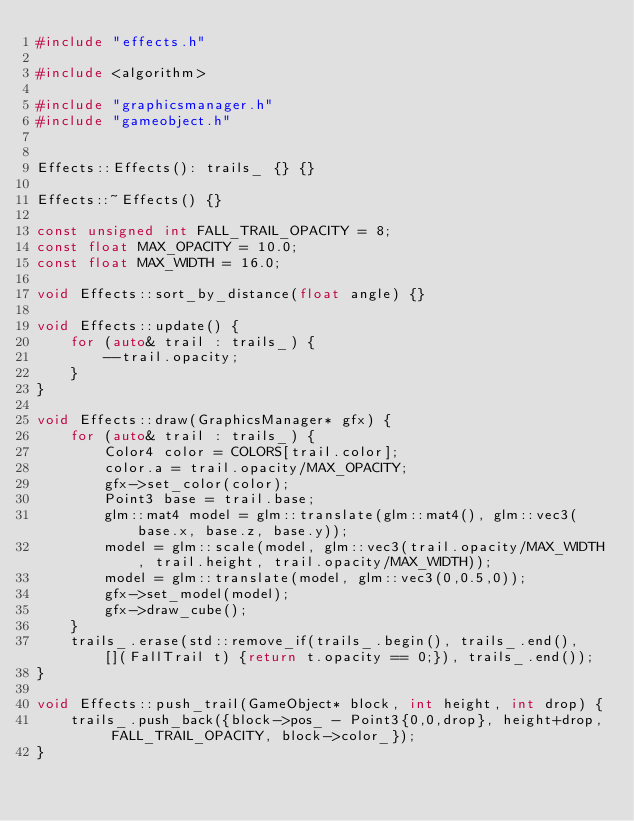<code> <loc_0><loc_0><loc_500><loc_500><_C++_>#include "effects.h"

#include <algorithm>

#include "graphicsmanager.h"
#include "gameobject.h"


Effects::Effects(): trails_ {} {}

Effects::~Effects() {}

const unsigned int FALL_TRAIL_OPACITY = 8;
const float MAX_OPACITY = 10.0;
const float MAX_WIDTH = 16.0;

void Effects::sort_by_distance(float angle) {}

void Effects::update() {
    for (auto& trail : trails_) {
        --trail.opacity;
    }
}

void Effects::draw(GraphicsManager* gfx) {
    for (auto& trail : trails_) {
        Color4 color = COLORS[trail.color];
        color.a = trail.opacity/MAX_OPACITY;
        gfx->set_color(color);
        Point3 base = trail.base;
        glm::mat4 model = glm::translate(glm::mat4(), glm::vec3(base.x, base.z, base.y));
        model = glm::scale(model, glm::vec3(trail.opacity/MAX_WIDTH, trail.height, trail.opacity/MAX_WIDTH));
        model = glm::translate(model, glm::vec3(0,0.5,0));
        gfx->set_model(model);
        gfx->draw_cube();
    }
    trails_.erase(std::remove_if(trails_.begin(), trails_.end(), [](FallTrail t) {return t.opacity == 0;}), trails_.end());
}

void Effects::push_trail(GameObject* block, int height, int drop) {
    trails_.push_back({block->pos_ - Point3{0,0,drop}, height+drop, FALL_TRAIL_OPACITY, block->color_});
}
</code> 